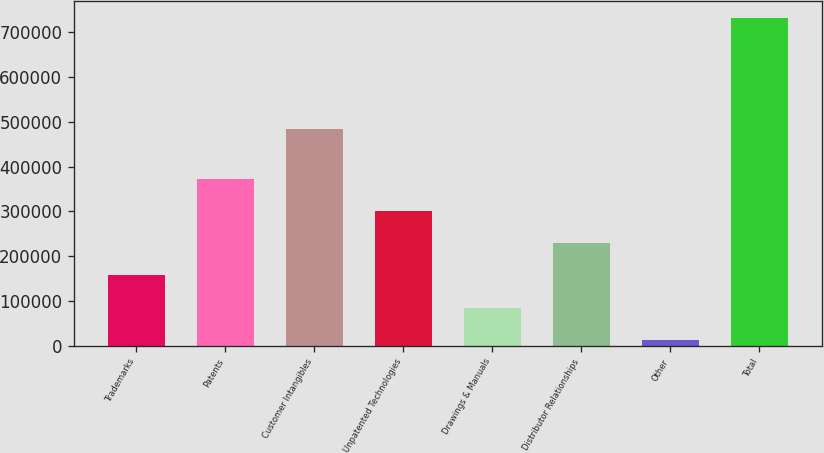Convert chart. <chart><loc_0><loc_0><loc_500><loc_500><bar_chart><fcel>Trademarks<fcel>Patents<fcel>Customer Intangibles<fcel>Unpatented Technologies<fcel>Drawings & Manuals<fcel>Distributor Relationships<fcel>Other<fcel>Total<nl><fcel>156798<fcel>372890<fcel>484449<fcel>300859<fcel>84767.6<fcel>228829<fcel>12737<fcel>733043<nl></chart> 